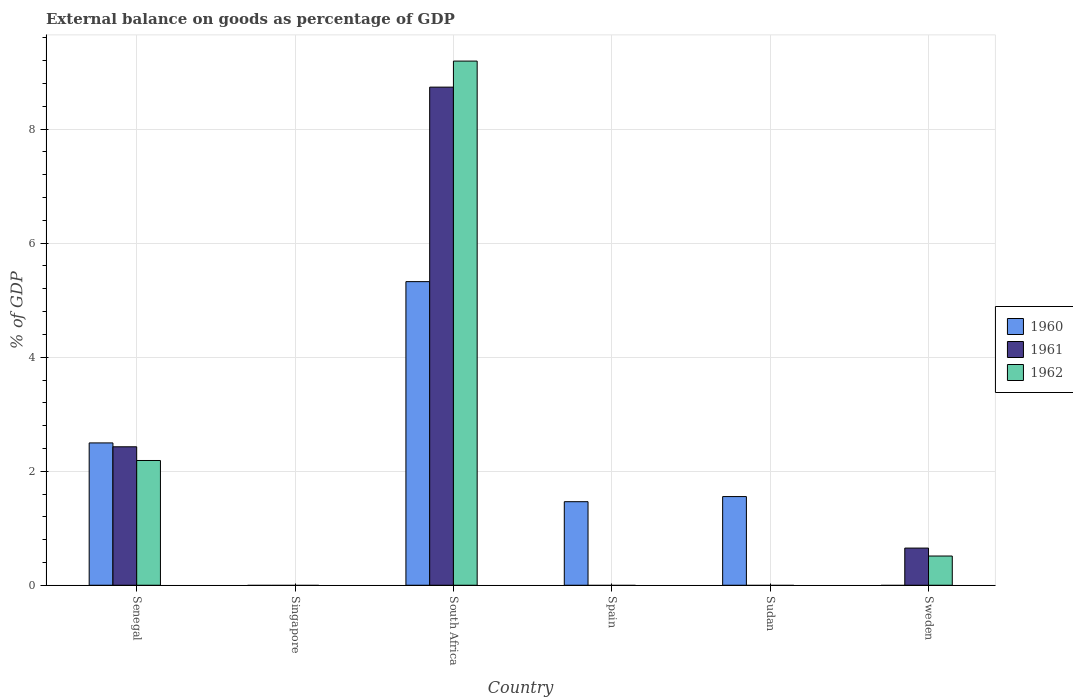How many different coloured bars are there?
Your answer should be very brief. 3. Are the number of bars on each tick of the X-axis equal?
Ensure brevity in your answer.  No. How many bars are there on the 4th tick from the left?
Give a very brief answer. 1. How many bars are there on the 6th tick from the right?
Your answer should be compact. 3. What is the label of the 5th group of bars from the left?
Your response must be concise. Sudan. What is the external balance on goods as percentage of GDP in 1962 in Sudan?
Offer a terse response. 0. Across all countries, what is the maximum external balance on goods as percentage of GDP in 1960?
Give a very brief answer. 5.33. Across all countries, what is the minimum external balance on goods as percentage of GDP in 1960?
Ensure brevity in your answer.  0. In which country was the external balance on goods as percentage of GDP in 1962 maximum?
Provide a succinct answer. South Africa. What is the total external balance on goods as percentage of GDP in 1962 in the graph?
Give a very brief answer. 11.89. What is the difference between the external balance on goods as percentage of GDP in 1962 in Senegal and the external balance on goods as percentage of GDP in 1960 in Spain?
Provide a succinct answer. 0.72. What is the average external balance on goods as percentage of GDP in 1962 per country?
Ensure brevity in your answer.  1.98. What is the difference between the external balance on goods as percentage of GDP of/in 1960 and external balance on goods as percentage of GDP of/in 1961 in Senegal?
Offer a very short reply. 0.07. What is the ratio of the external balance on goods as percentage of GDP in 1961 in Senegal to that in Sweden?
Offer a very short reply. 3.73. What is the difference between the highest and the second highest external balance on goods as percentage of GDP in 1960?
Give a very brief answer. -0.94. What is the difference between the highest and the lowest external balance on goods as percentage of GDP in 1960?
Make the answer very short. 5.33. In how many countries, is the external balance on goods as percentage of GDP in 1960 greater than the average external balance on goods as percentage of GDP in 1960 taken over all countries?
Ensure brevity in your answer.  2. What is the difference between two consecutive major ticks on the Y-axis?
Provide a short and direct response. 2. Are the values on the major ticks of Y-axis written in scientific E-notation?
Keep it short and to the point. No. How many legend labels are there?
Ensure brevity in your answer.  3. How are the legend labels stacked?
Make the answer very short. Vertical. What is the title of the graph?
Ensure brevity in your answer.  External balance on goods as percentage of GDP. Does "1984" appear as one of the legend labels in the graph?
Keep it short and to the point. No. What is the label or title of the Y-axis?
Ensure brevity in your answer.  % of GDP. What is the % of GDP of 1960 in Senegal?
Provide a succinct answer. 2.5. What is the % of GDP in 1961 in Senegal?
Give a very brief answer. 2.43. What is the % of GDP in 1962 in Senegal?
Your answer should be compact. 2.19. What is the % of GDP of 1960 in Singapore?
Offer a very short reply. 0. What is the % of GDP in 1962 in Singapore?
Your response must be concise. 0. What is the % of GDP of 1960 in South Africa?
Give a very brief answer. 5.33. What is the % of GDP in 1961 in South Africa?
Keep it short and to the point. 8.74. What is the % of GDP in 1962 in South Africa?
Make the answer very short. 9.19. What is the % of GDP of 1960 in Spain?
Your answer should be very brief. 1.47. What is the % of GDP in 1961 in Spain?
Provide a short and direct response. 0. What is the % of GDP in 1960 in Sudan?
Provide a short and direct response. 1.56. What is the % of GDP in 1961 in Sweden?
Ensure brevity in your answer.  0.65. What is the % of GDP of 1962 in Sweden?
Make the answer very short. 0.51. Across all countries, what is the maximum % of GDP of 1960?
Your answer should be very brief. 5.33. Across all countries, what is the maximum % of GDP in 1961?
Give a very brief answer. 8.74. Across all countries, what is the maximum % of GDP of 1962?
Provide a short and direct response. 9.19. Across all countries, what is the minimum % of GDP of 1960?
Ensure brevity in your answer.  0. What is the total % of GDP in 1960 in the graph?
Keep it short and to the point. 10.84. What is the total % of GDP of 1961 in the graph?
Give a very brief answer. 11.82. What is the total % of GDP in 1962 in the graph?
Make the answer very short. 11.89. What is the difference between the % of GDP of 1960 in Senegal and that in South Africa?
Make the answer very short. -2.83. What is the difference between the % of GDP of 1961 in Senegal and that in South Africa?
Make the answer very short. -6.31. What is the difference between the % of GDP in 1962 in Senegal and that in South Africa?
Offer a terse response. -7.01. What is the difference between the % of GDP in 1960 in Senegal and that in Spain?
Give a very brief answer. 1.03. What is the difference between the % of GDP in 1960 in Senegal and that in Sudan?
Give a very brief answer. 0.94. What is the difference between the % of GDP in 1961 in Senegal and that in Sweden?
Provide a succinct answer. 1.78. What is the difference between the % of GDP of 1962 in Senegal and that in Sweden?
Your answer should be very brief. 1.68. What is the difference between the % of GDP of 1960 in South Africa and that in Spain?
Offer a very short reply. 3.86. What is the difference between the % of GDP of 1960 in South Africa and that in Sudan?
Offer a terse response. 3.77. What is the difference between the % of GDP in 1961 in South Africa and that in Sweden?
Your answer should be very brief. 8.09. What is the difference between the % of GDP in 1962 in South Africa and that in Sweden?
Give a very brief answer. 8.68. What is the difference between the % of GDP in 1960 in Spain and that in Sudan?
Provide a succinct answer. -0.09. What is the difference between the % of GDP of 1960 in Senegal and the % of GDP of 1961 in South Africa?
Offer a very short reply. -6.24. What is the difference between the % of GDP of 1960 in Senegal and the % of GDP of 1962 in South Africa?
Your answer should be very brief. -6.7. What is the difference between the % of GDP in 1961 in Senegal and the % of GDP in 1962 in South Africa?
Ensure brevity in your answer.  -6.77. What is the difference between the % of GDP of 1960 in Senegal and the % of GDP of 1961 in Sweden?
Offer a terse response. 1.84. What is the difference between the % of GDP in 1960 in Senegal and the % of GDP in 1962 in Sweden?
Your answer should be compact. 1.98. What is the difference between the % of GDP of 1961 in Senegal and the % of GDP of 1962 in Sweden?
Make the answer very short. 1.92. What is the difference between the % of GDP in 1960 in South Africa and the % of GDP in 1961 in Sweden?
Your answer should be very brief. 4.67. What is the difference between the % of GDP in 1960 in South Africa and the % of GDP in 1962 in Sweden?
Offer a terse response. 4.81. What is the difference between the % of GDP in 1961 in South Africa and the % of GDP in 1962 in Sweden?
Your answer should be very brief. 8.22. What is the difference between the % of GDP in 1960 in Spain and the % of GDP in 1961 in Sweden?
Provide a short and direct response. 0.81. What is the difference between the % of GDP in 1960 in Spain and the % of GDP in 1962 in Sweden?
Provide a succinct answer. 0.95. What is the difference between the % of GDP of 1960 in Sudan and the % of GDP of 1961 in Sweden?
Provide a short and direct response. 0.9. What is the difference between the % of GDP in 1960 in Sudan and the % of GDP in 1962 in Sweden?
Your answer should be compact. 1.04. What is the average % of GDP in 1960 per country?
Provide a succinct answer. 1.81. What is the average % of GDP of 1961 per country?
Offer a very short reply. 1.97. What is the average % of GDP of 1962 per country?
Keep it short and to the point. 1.98. What is the difference between the % of GDP of 1960 and % of GDP of 1961 in Senegal?
Provide a succinct answer. 0.07. What is the difference between the % of GDP in 1960 and % of GDP in 1962 in Senegal?
Give a very brief answer. 0.31. What is the difference between the % of GDP of 1961 and % of GDP of 1962 in Senegal?
Offer a terse response. 0.24. What is the difference between the % of GDP of 1960 and % of GDP of 1961 in South Africa?
Your response must be concise. -3.41. What is the difference between the % of GDP of 1960 and % of GDP of 1962 in South Africa?
Ensure brevity in your answer.  -3.87. What is the difference between the % of GDP in 1961 and % of GDP in 1962 in South Africa?
Offer a very short reply. -0.46. What is the difference between the % of GDP in 1961 and % of GDP in 1962 in Sweden?
Your response must be concise. 0.14. What is the ratio of the % of GDP of 1960 in Senegal to that in South Africa?
Provide a succinct answer. 0.47. What is the ratio of the % of GDP in 1961 in Senegal to that in South Africa?
Your answer should be compact. 0.28. What is the ratio of the % of GDP in 1962 in Senegal to that in South Africa?
Ensure brevity in your answer.  0.24. What is the ratio of the % of GDP of 1960 in Senegal to that in Spain?
Your answer should be very brief. 1.7. What is the ratio of the % of GDP of 1960 in Senegal to that in Sudan?
Your answer should be very brief. 1.61. What is the ratio of the % of GDP in 1961 in Senegal to that in Sweden?
Your response must be concise. 3.73. What is the ratio of the % of GDP of 1962 in Senegal to that in Sweden?
Provide a short and direct response. 4.27. What is the ratio of the % of GDP of 1960 in South Africa to that in Spain?
Your answer should be compact. 3.63. What is the ratio of the % of GDP in 1960 in South Africa to that in Sudan?
Offer a terse response. 3.42. What is the ratio of the % of GDP in 1961 in South Africa to that in Sweden?
Provide a short and direct response. 13.41. What is the ratio of the % of GDP of 1962 in South Africa to that in Sweden?
Provide a succinct answer. 17.94. What is the ratio of the % of GDP in 1960 in Spain to that in Sudan?
Offer a very short reply. 0.94. What is the difference between the highest and the second highest % of GDP in 1960?
Offer a very short reply. 2.83. What is the difference between the highest and the second highest % of GDP of 1961?
Make the answer very short. 6.31. What is the difference between the highest and the second highest % of GDP of 1962?
Give a very brief answer. 7.01. What is the difference between the highest and the lowest % of GDP of 1960?
Ensure brevity in your answer.  5.33. What is the difference between the highest and the lowest % of GDP of 1961?
Your answer should be very brief. 8.74. What is the difference between the highest and the lowest % of GDP of 1962?
Your answer should be very brief. 9.19. 